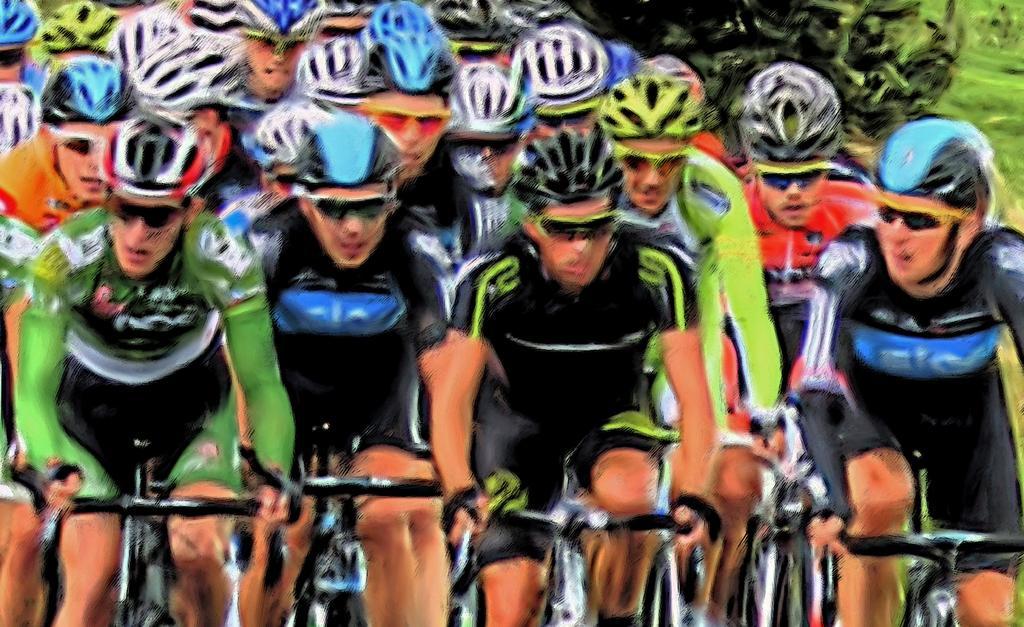Please provide a concise description of this image. In this image, in the middle there is a man, he wears a t shirt, trouser, helmet, he is riding a bicycle. On the right there is a man, he wears a t shirt, trouser, helmet, he is riding a bicycle. On the left there is a man, he wears a t shirt, trouser, helmet, he is riding a bicycle. In the background there are people riding bicycles and there is greenery. 